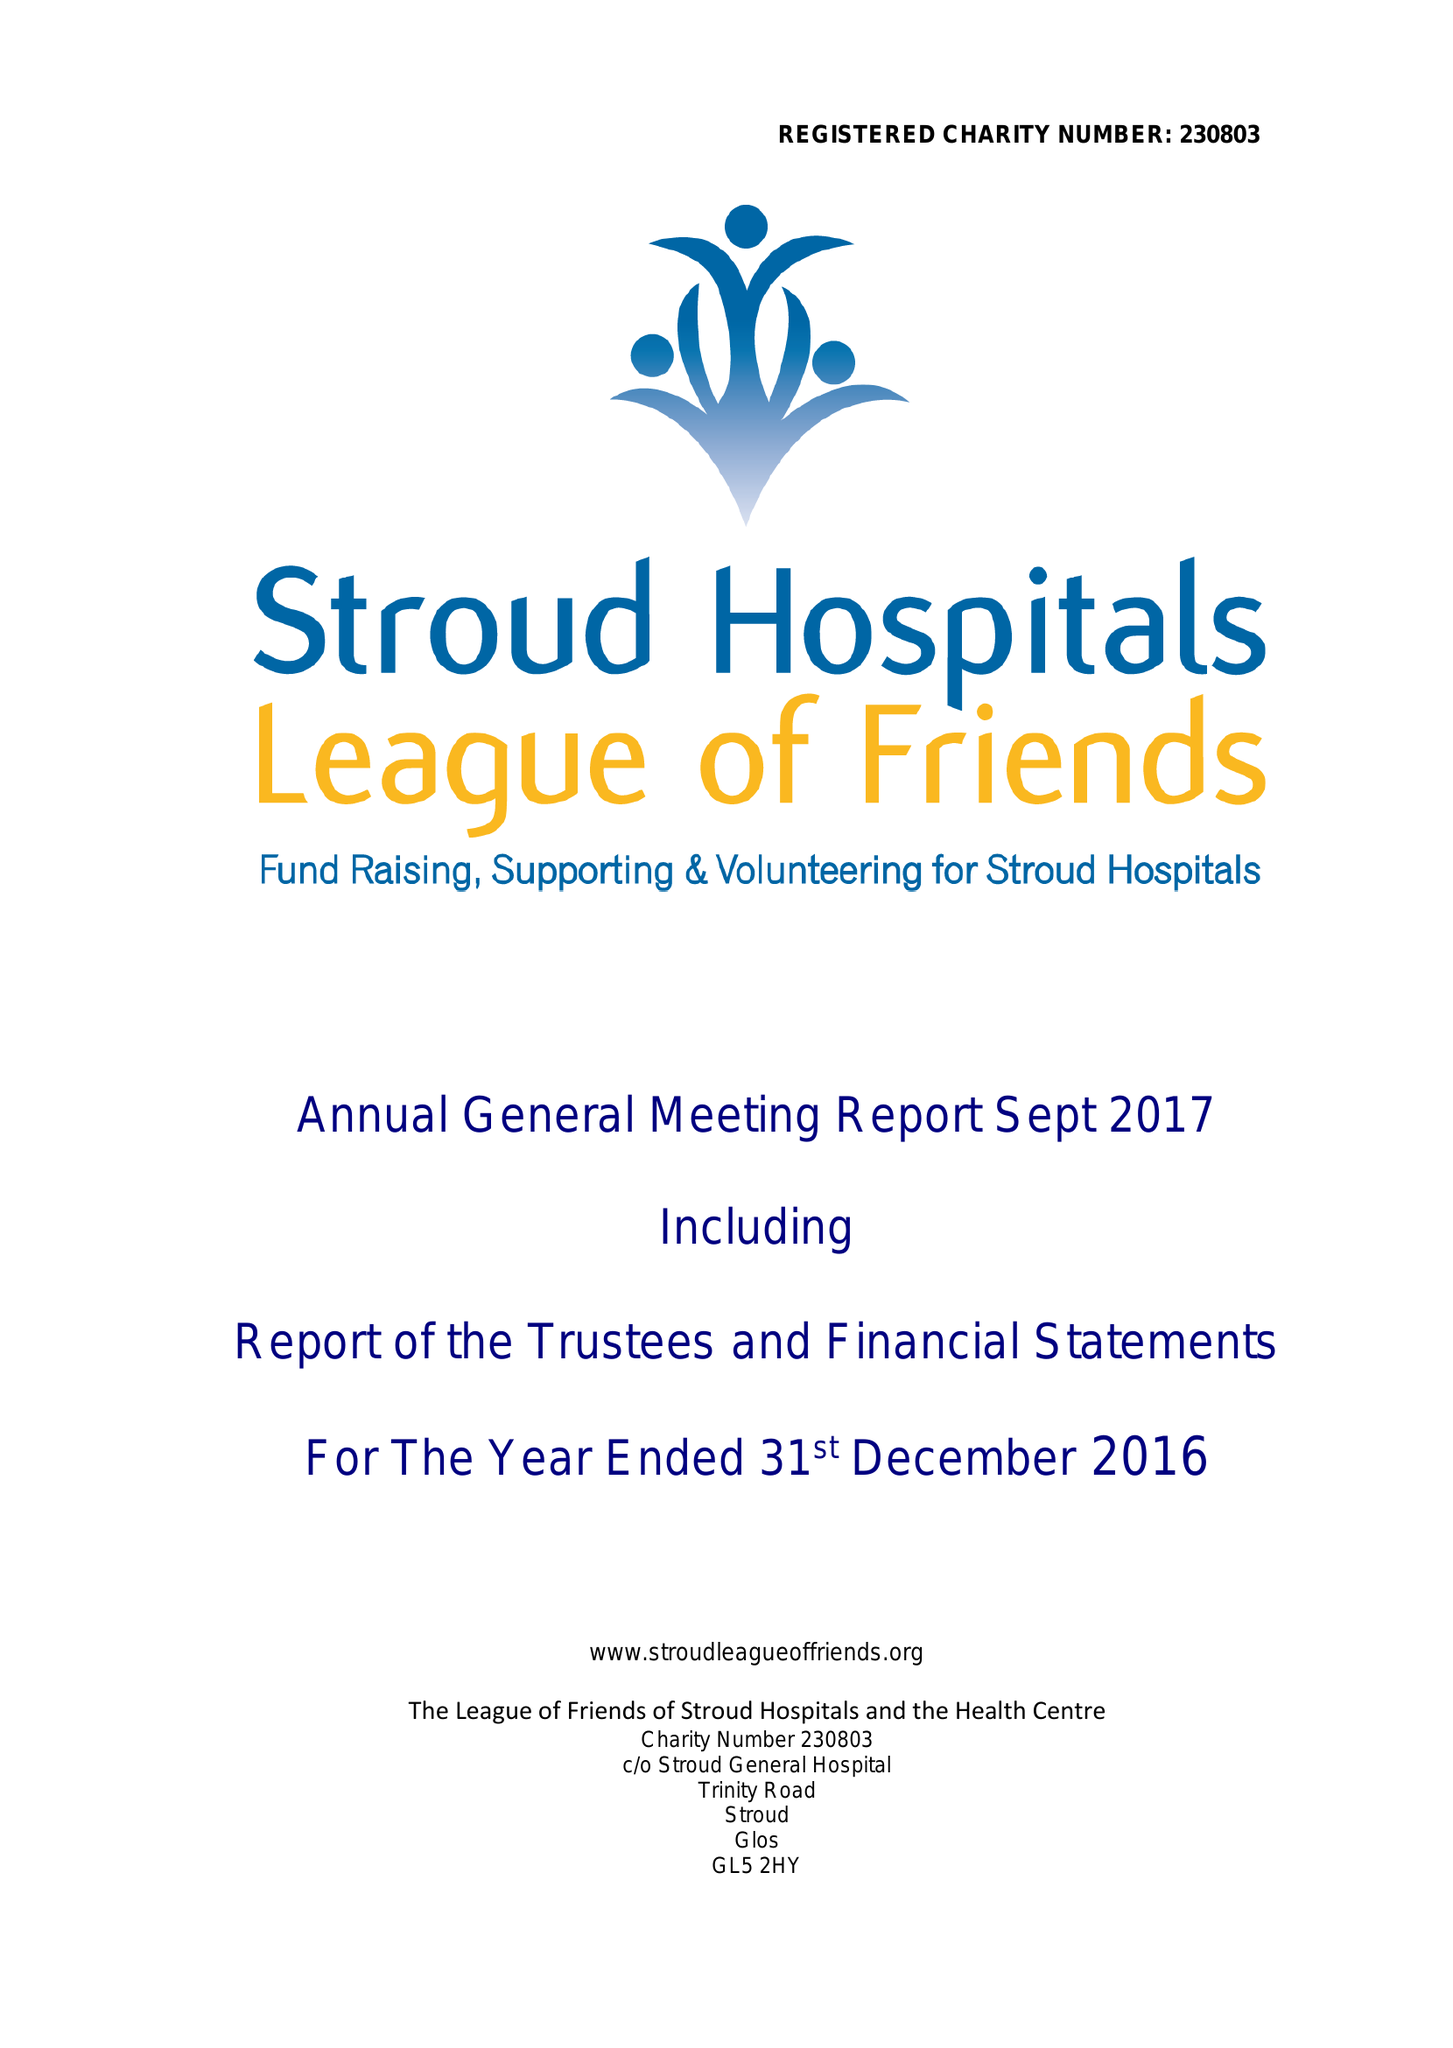What is the value for the income_annually_in_british_pounds?
Answer the question using a single word or phrase. 363162.00 